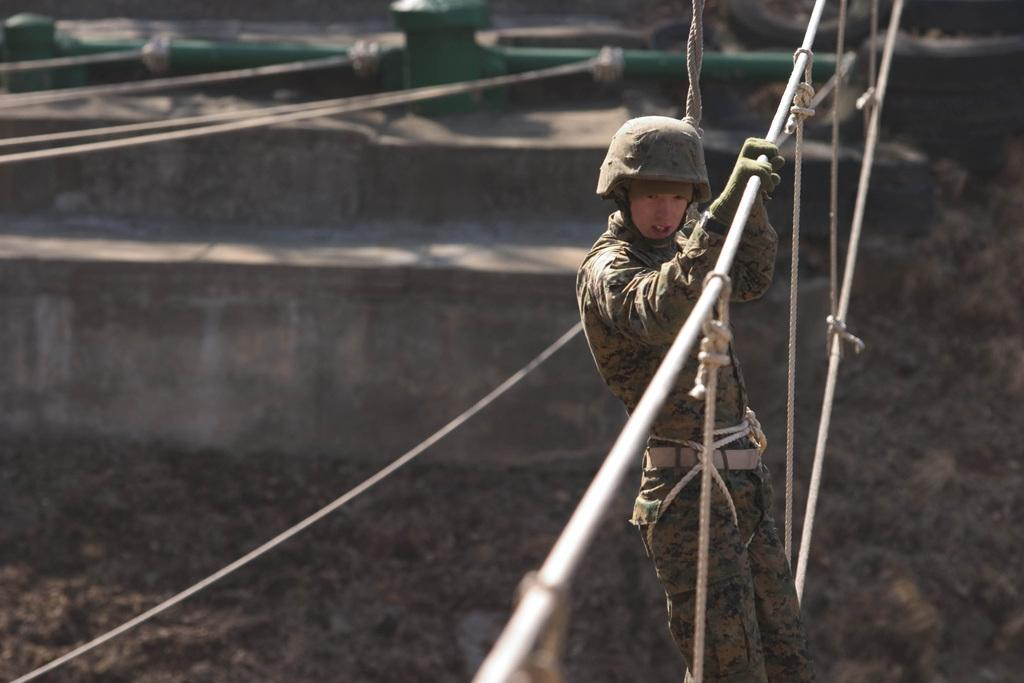What is the person in the image wearing on their head? The person in the image is wearing a helmet. What type of protective gear is the person wearing on their hands? The person is wearing gloves. What position is the person in? The person is standing. What can be seen in the background of the image? There are ropes, a pipe, a wall, and some objects in the background of the image. What type of sofa is visible in the image? There is no sofa present in the image. Is the person in the image reading a book? There is no book visible in the image, and the person's activity is not specified. 